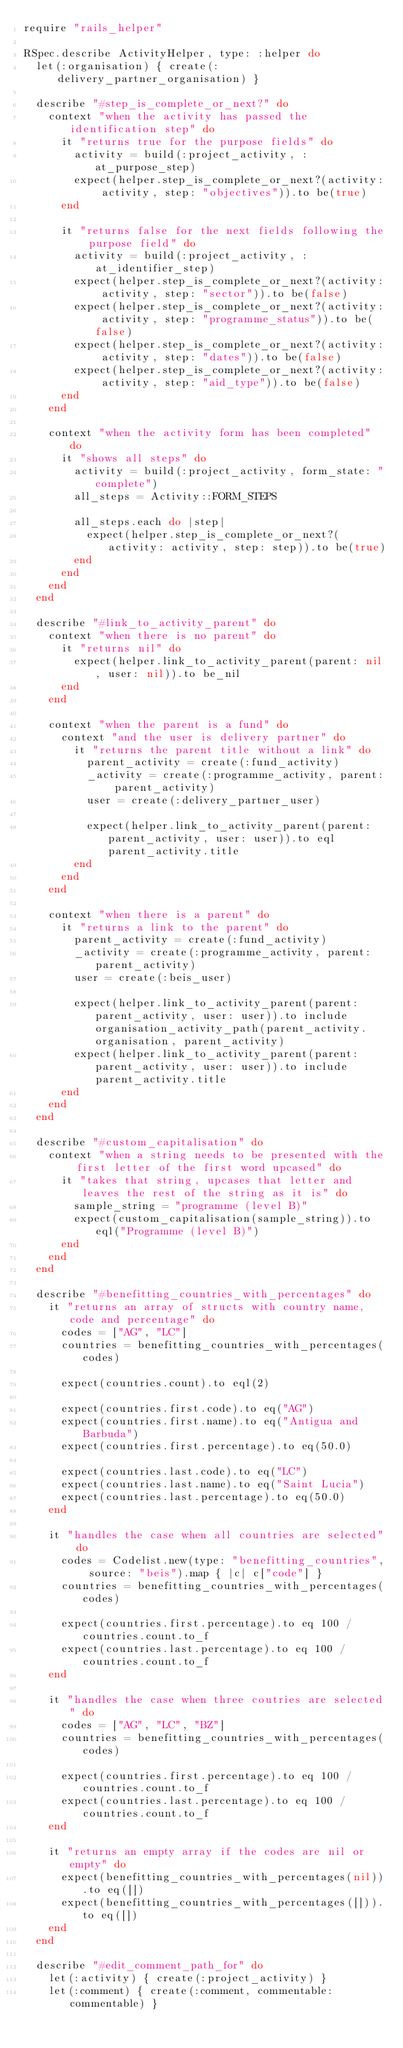Convert code to text. <code><loc_0><loc_0><loc_500><loc_500><_Ruby_>require "rails_helper"

RSpec.describe ActivityHelper, type: :helper do
  let(:organisation) { create(:delivery_partner_organisation) }

  describe "#step_is_complete_or_next?" do
    context "when the activity has passed the identification step" do
      it "returns true for the purpose fields" do
        activity = build(:project_activity, :at_purpose_step)
        expect(helper.step_is_complete_or_next?(activity: activity, step: "objectives")).to be(true)
      end

      it "returns false for the next fields following the purpose field" do
        activity = build(:project_activity, :at_identifier_step)
        expect(helper.step_is_complete_or_next?(activity: activity, step: "sector")).to be(false)
        expect(helper.step_is_complete_or_next?(activity: activity, step: "programme_status")).to be(false)
        expect(helper.step_is_complete_or_next?(activity: activity, step: "dates")).to be(false)
        expect(helper.step_is_complete_or_next?(activity: activity, step: "aid_type")).to be(false)
      end
    end

    context "when the activity form has been completed" do
      it "shows all steps" do
        activity = build(:project_activity, form_state: "complete")
        all_steps = Activity::FORM_STEPS

        all_steps.each do |step|
          expect(helper.step_is_complete_or_next?(activity: activity, step: step)).to be(true)
        end
      end
    end
  end

  describe "#link_to_activity_parent" do
    context "when there is no parent" do
      it "returns nil" do
        expect(helper.link_to_activity_parent(parent: nil, user: nil)).to be_nil
      end
    end

    context "when the parent is a fund" do
      context "and the user is delivery partner" do
        it "returns the parent title without a link" do
          parent_activity = create(:fund_activity)
          _activity = create(:programme_activity, parent: parent_activity)
          user = create(:delivery_partner_user)

          expect(helper.link_to_activity_parent(parent: parent_activity, user: user)).to eql parent_activity.title
        end
      end
    end

    context "when there is a parent" do
      it "returns a link to the parent" do
        parent_activity = create(:fund_activity)
        _activity = create(:programme_activity, parent: parent_activity)
        user = create(:beis_user)

        expect(helper.link_to_activity_parent(parent: parent_activity, user: user)).to include organisation_activity_path(parent_activity.organisation, parent_activity)
        expect(helper.link_to_activity_parent(parent: parent_activity, user: user)).to include parent_activity.title
      end
    end
  end

  describe "#custom_capitalisation" do
    context "when a string needs to be presented with the first letter of the first word upcased" do
      it "takes that string, upcases that letter and leaves the rest of the string as it is" do
        sample_string = "programme (level B)"
        expect(custom_capitalisation(sample_string)).to eql("Programme (level B)")
      end
    end
  end

  describe "#benefitting_countries_with_percentages" do
    it "returns an array of structs with country name, code and percentage" do
      codes = ["AG", "LC"]
      countries = benefitting_countries_with_percentages(codes)

      expect(countries.count).to eql(2)

      expect(countries.first.code).to eq("AG")
      expect(countries.first.name).to eq("Antigua and Barbuda")
      expect(countries.first.percentage).to eq(50.0)

      expect(countries.last.code).to eq("LC")
      expect(countries.last.name).to eq("Saint Lucia")
      expect(countries.last.percentage).to eq(50.0)
    end

    it "handles the case when all countries are selected" do
      codes = Codelist.new(type: "benefitting_countries", source: "beis").map { |c| c["code"] }
      countries = benefitting_countries_with_percentages(codes)

      expect(countries.first.percentage).to eq 100 / countries.count.to_f
      expect(countries.last.percentage).to eq 100 / countries.count.to_f
    end

    it "handles the case when three coutries are selected" do
      codes = ["AG", "LC", "BZ"]
      countries = benefitting_countries_with_percentages(codes)

      expect(countries.first.percentage).to eq 100 / countries.count.to_f
      expect(countries.last.percentage).to eq 100 / countries.count.to_f
    end

    it "returns an empty array if the codes are nil or empty" do
      expect(benefitting_countries_with_percentages(nil)).to eq([])
      expect(benefitting_countries_with_percentages([])).to eq([])
    end
  end

  describe "#edit_comment_path_for" do
    let(:activity) { create(:project_activity) }
    let(:comment) { create(:comment, commentable: commentable) }
</code> 